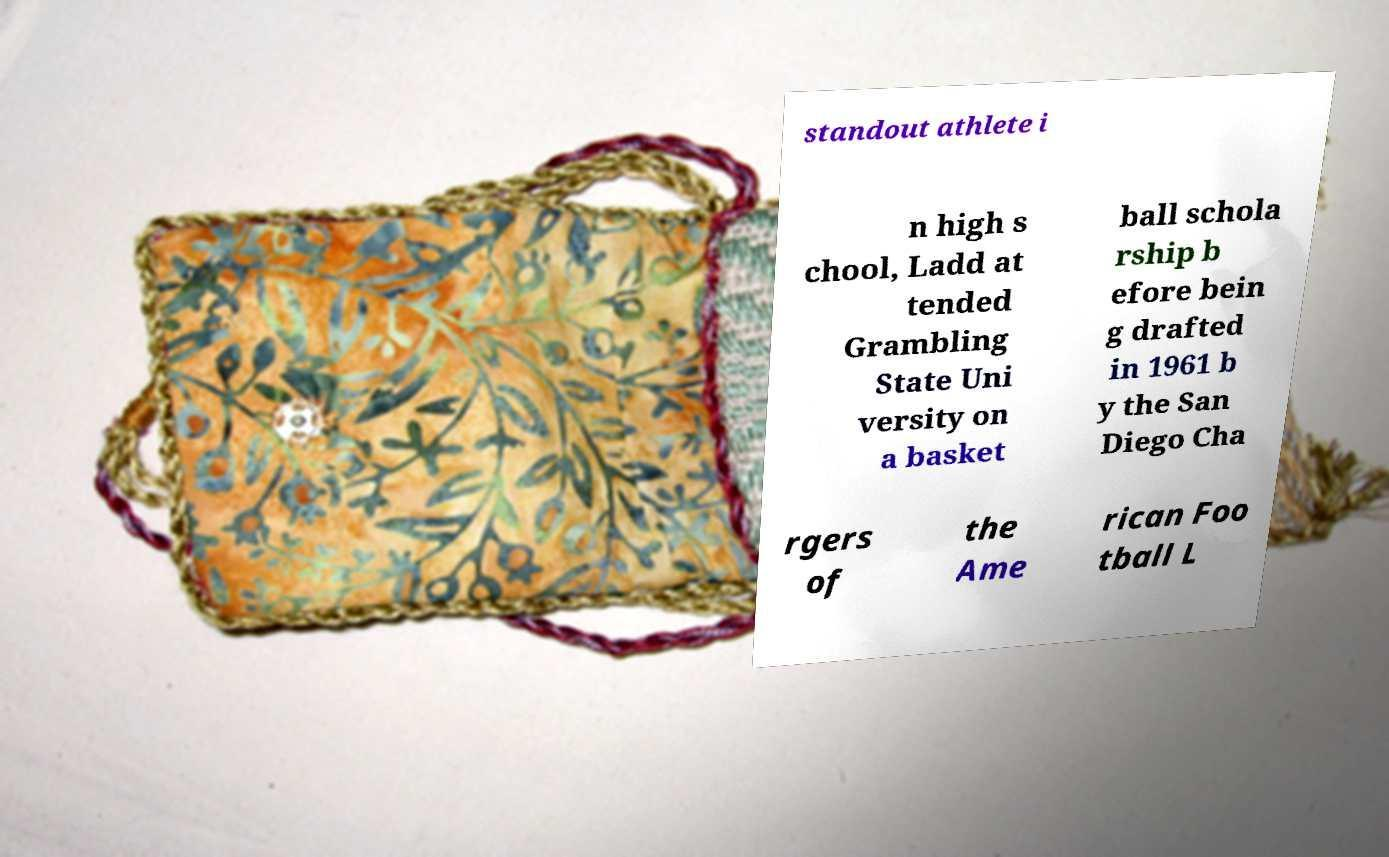For documentation purposes, I need the text within this image transcribed. Could you provide that? standout athlete i n high s chool, Ladd at tended Grambling State Uni versity on a basket ball schola rship b efore bein g drafted in 1961 b y the San Diego Cha rgers of the Ame rican Foo tball L 